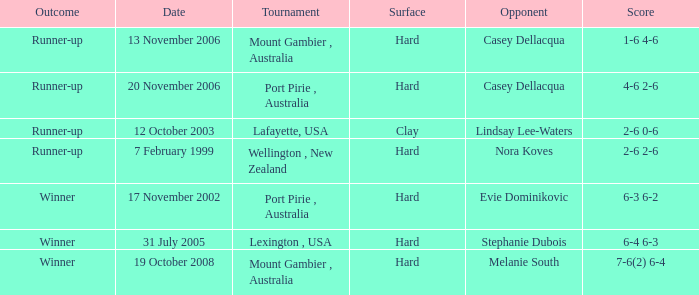When is a rival competing against evie dominikovic? 17 November 2002. 